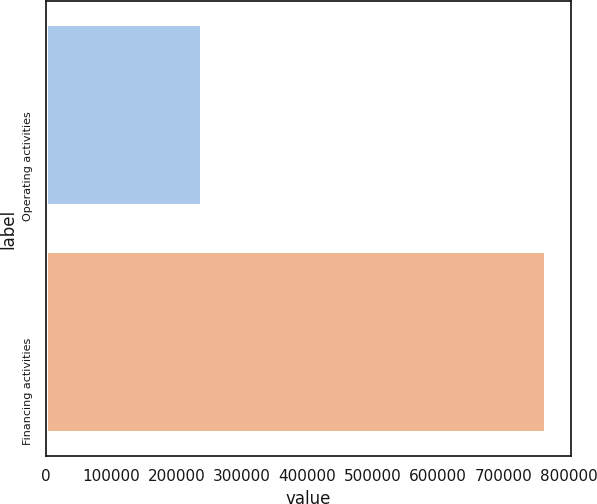<chart> <loc_0><loc_0><loc_500><loc_500><bar_chart><fcel>Operating activities<fcel>Financing activities<nl><fcel>238228<fcel>764350<nl></chart> 